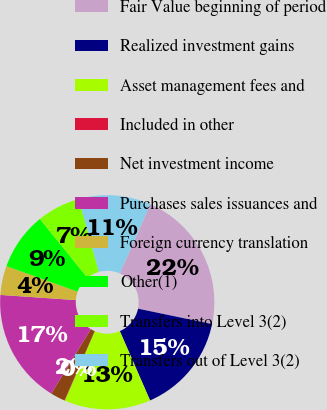<chart> <loc_0><loc_0><loc_500><loc_500><pie_chart><fcel>Fair Value beginning of period<fcel>Realized investment gains<fcel>Asset management fees and<fcel>Included in other<fcel>Net investment income<fcel>Purchases sales issuances and<fcel>Foreign currency translation<fcel>Other(1)<fcel>Transfers into Level 3(2)<fcel>Transfers out of Level 3(2)<nl><fcel>21.68%<fcel>15.19%<fcel>13.03%<fcel>0.05%<fcel>2.21%<fcel>17.35%<fcel>4.38%<fcel>8.7%<fcel>6.54%<fcel>10.87%<nl></chart> 